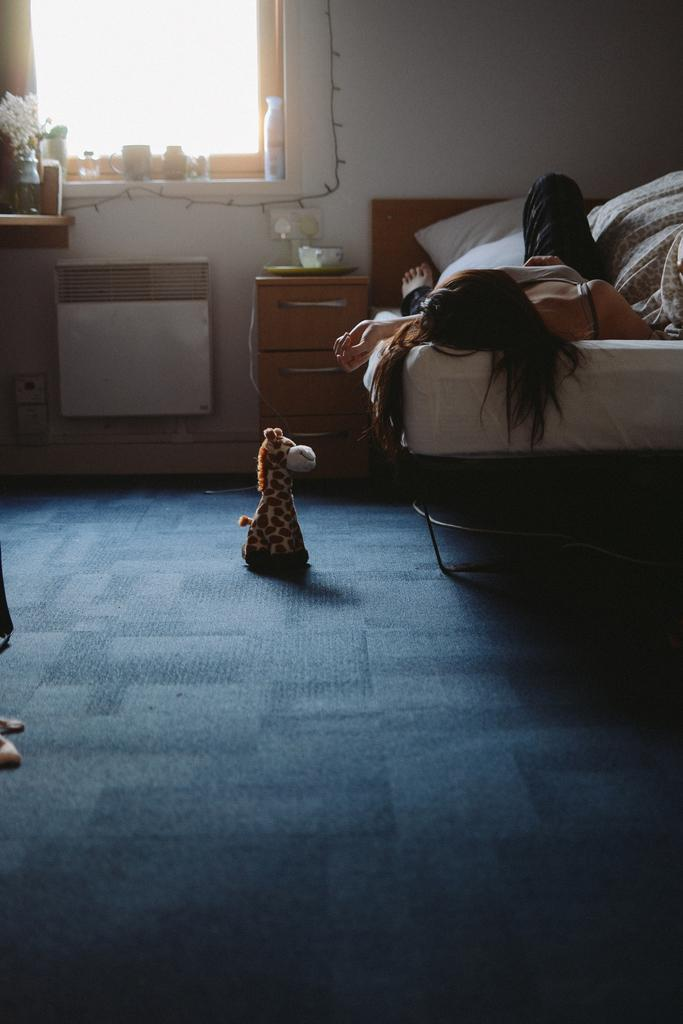What is the woman doing in the image? The woman is lying on the bed in the image. What is on the bed with the woman? There is a pillow on the bed. What can be seen in the background of the image? There is a window in the image. What is on the table in the image? There is a flower vase on a table in the image. What is on the floor in the image? There is a toy on the floor in the image. What type of hook is the carpenter using to hang the morning sun in the image? There is no carpenter, hook, or morning sun present in the image. 